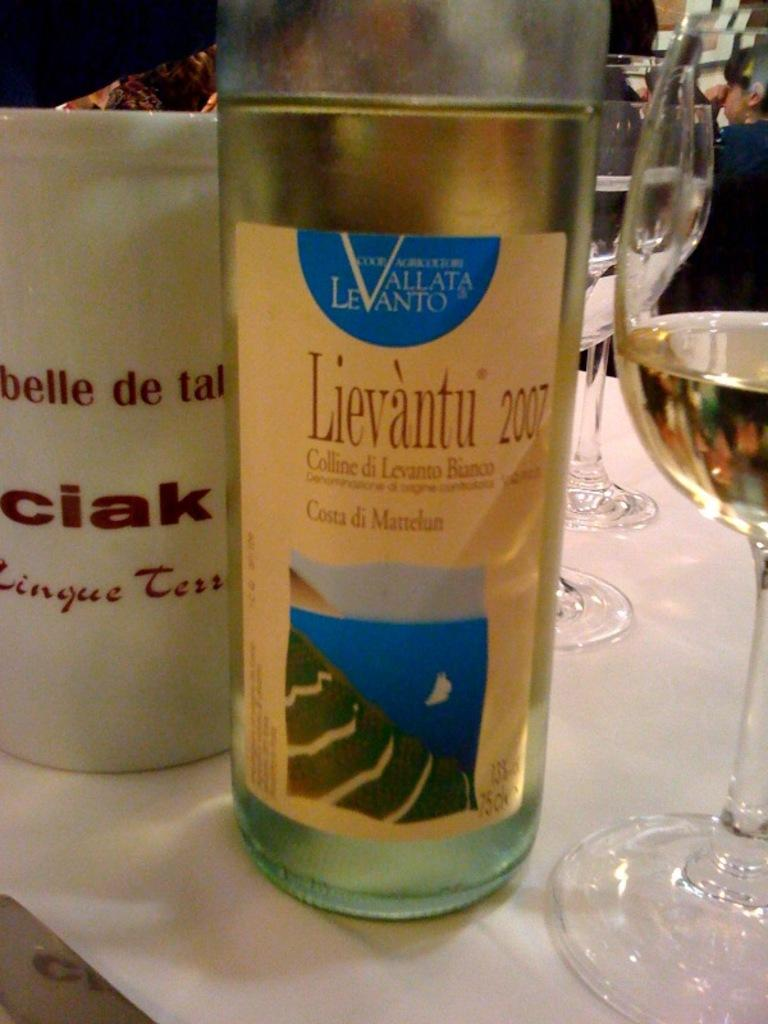<image>
Describe the image concisely. A bottle of wine is on a table and it says Lievantu 2007. 